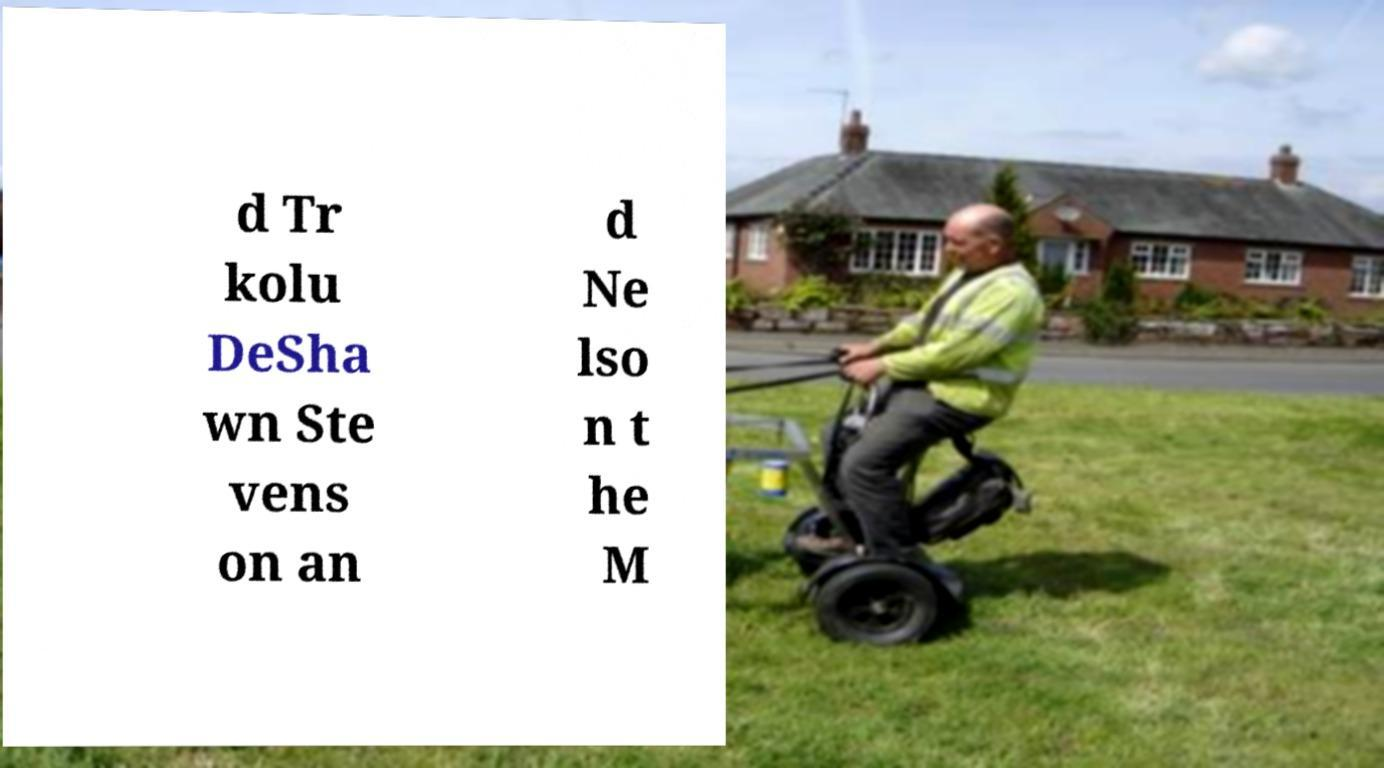Please identify and transcribe the text found in this image. d Tr kolu DeSha wn Ste vens on an d Ne lso n t he M 